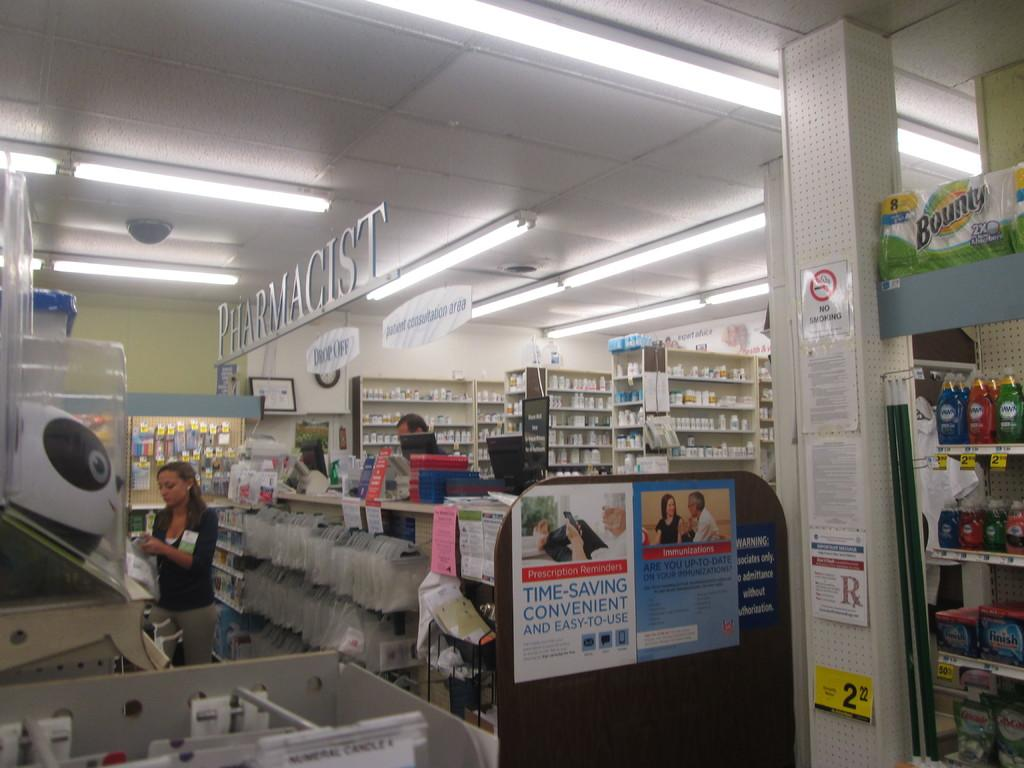Provide a one-sentence caption for the provided image. A sign at the pharmacy reads "time-saving convenient and easy to use". 